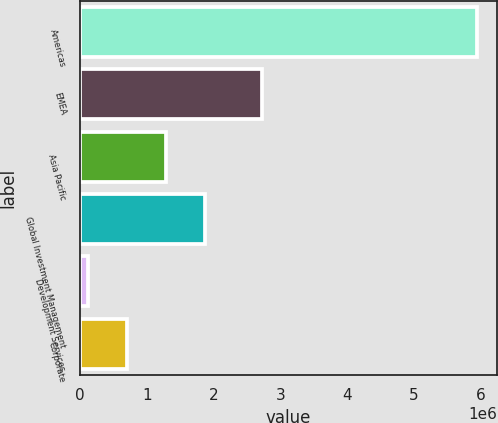<chart> <loc_0><loc_0><loc_500><loc_500><bar_chart><fcel>Americas<fcel>EMEA<fcel>Asia Pacific<fcel>Global Investment Management<fcel>Development Services<fcel>Corporate<nl><fcel>5.9404e+06<fcel>2.72272e+06<fcel>1.28785e+06<fcel>1.86942e+06<fcel>124715<fcel>706284<nl></chart> 